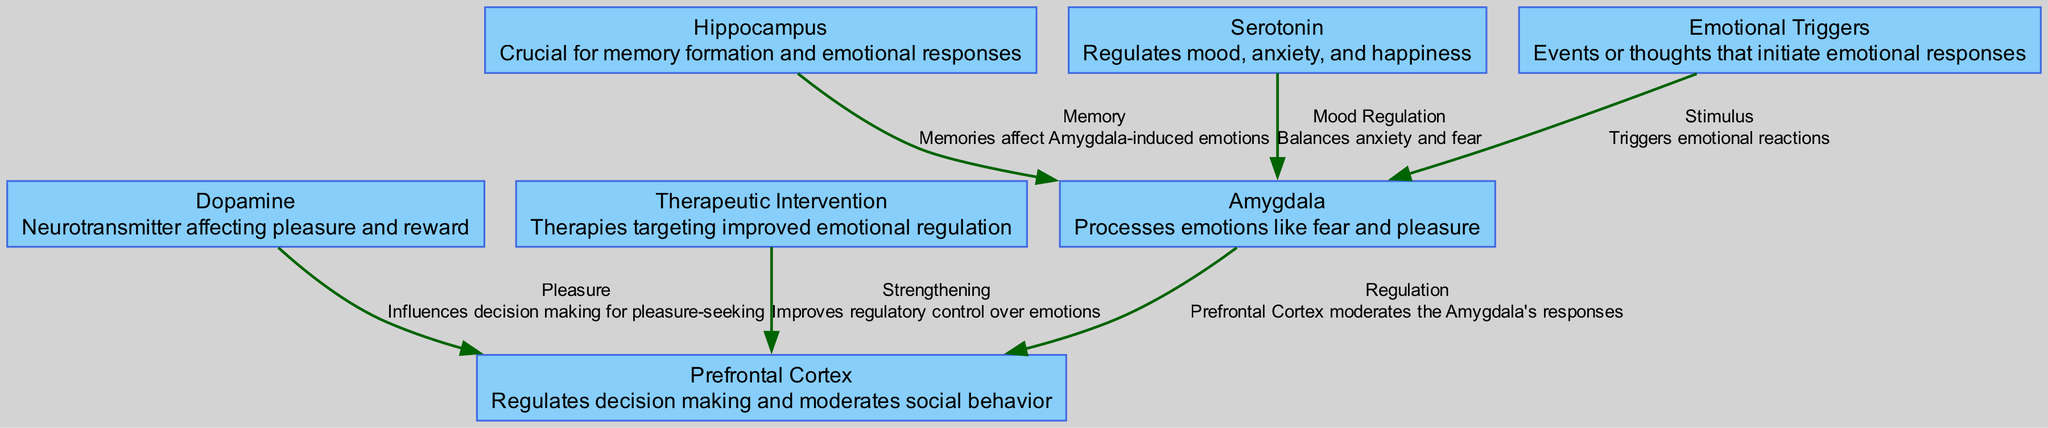What are the two primary areas of the brain involved in emotional regulation? The diagram presents two main areas involved: the Amygdala and the Prefrontal Cortex, as both nodes are highlighted for their roles in processing emotions and regulating responses.
Answer: Amygdala, Prefrontal Cortex How many nodes are present in the diagram? The diagram has six distinct nodes representing different brain parts and neurotransmitters involved in emotional regulation. By simply counting each unique node mentioned, the total is determined.
Answer: 6 What relationship exists between the Hippocampus and the Amygdala? The diagram indicates a relationship marked as "Memory," showing that the Hippocampus influences the Amygdala through emotional connections tied to memories. This information is clearly presented as an edge in the diagram.
Answer: Memory Which neurotransmitter is associated with mood regulation in the diagram? From the diagram, Serotonin is specifically linked to mood regulation, as indicated by the edge labeled "Mood Regulation" that connects Serotonin to the Amygdala. This reveals its function in balancing emotions.
Answer: Serotonin What is the effect of therapeutic intervention on the Prefrontal Cortex according to the diagram? The diagram shows that Therapeutic Intervention strengthens the Prefrontal Cortex's ability to regulate emotions. By considering the flow from the therapeutic node to the Prefrontal Cortex node, this relationship is established.
Answer: Strengthening What triggers emotional reactions based on the diagram? According to the diagram, Emotional Triggers are the specific events or thoughts that initiate emotional responses, as indicated by the edge connecting this node to the Amygdala.
Answer: Events, thoughts How does Dopamine influence the Prefrontal Cortex? The diagram illustrates that Dopamine influences decision-making for pleasure-seeking behavior, as indicated by the "Pleasure" label connecting Dopamine to the Prefrontal Cortex. This relationship highlights the effect of rewards on decisions.
Answer: Pleasure Which brain structure helps in memory formation? The diagram describes the Hippocampus as crucial for memory formation. The specific labeling of the Hippocampus node indicates its function in consolidating emotional memories.
Answer: Hippocampus Describe the role of Serotonin in relation to the Amygdala based on the diagram. The diagram portrays Serotonin's role in regulating mood by balancing anxiety and fear, as noted in the edge labeled "Mood Regulation" that connects Serotonin to the Amygdala. This indicates its moderating effect on emotional responses.
Answer: Balances anxiety and fear 